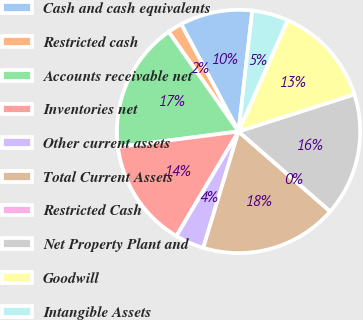Convert chart. <chart><loc_0><loc_0><loc_500><loc_500><pie_chart><fcel>Cash and cash equivalents<fcel>Restricted cash<fcel>Accounts receivable net<fcel>Inventories net<fcel>Other current assets<fcel>Total Current Assets<fcel>Restricted Cash<fcel>Net Property Plant and<fcel>Goodwill<fcel>Intangible Assets<nl><fcel>9.62%<fcel>1.92%<fcel>17.31%<fcel>14.42%<fcel>3.85%<fcel>18.27%<fcel>0.0%<fcel>16.35%<fcel>13.46%<fcel>4.81%<nl></chart> 